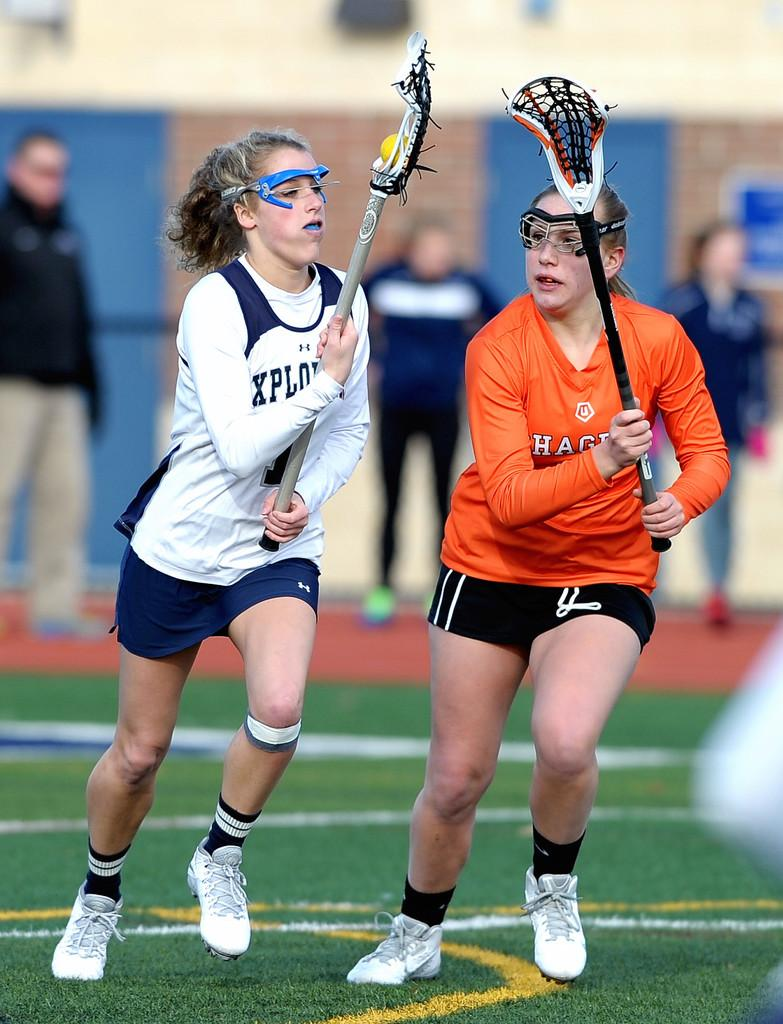What are the two people in the image doing? The two people in the image are running. What are the two people holding while running? The two people are holding objects. Can you describe the people in the background of the image? There are people standing in the background of the image. How would you describe the background of the image? The background of the image is blurred. What type of metal can be seen on the coast in the image? There is no coast or metal present in the image. 